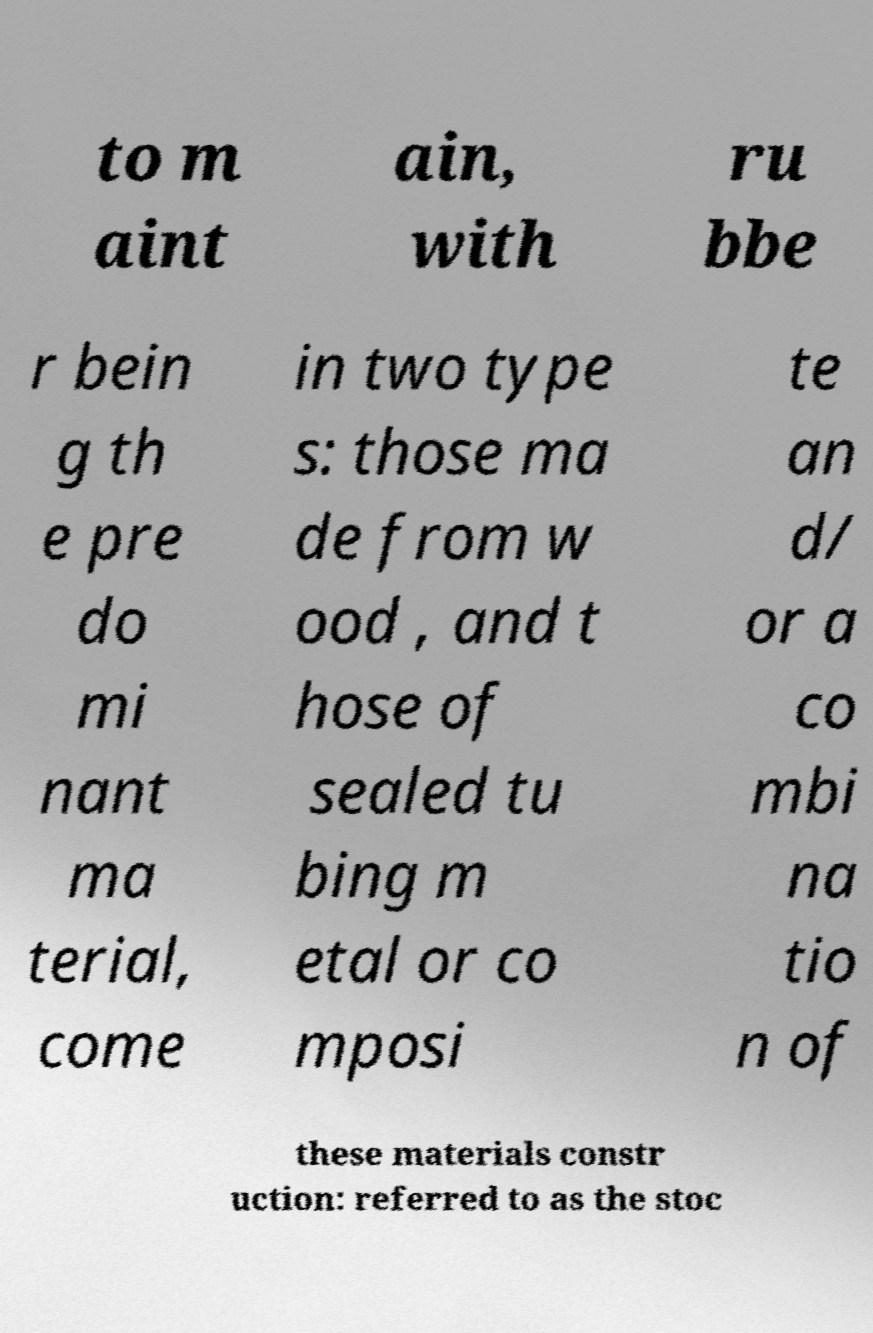I need the written content from this picture converted into text. Can you do that? to m aint ain, with ru bbe r bein g th e pre do mi nant ma terial, come in two type s: those ma de from w ood , and t hose of sealed tu bing m etal or co mposi te an d/ or a co mbi na tio n of these materials constr uction: referred to as the stoc 